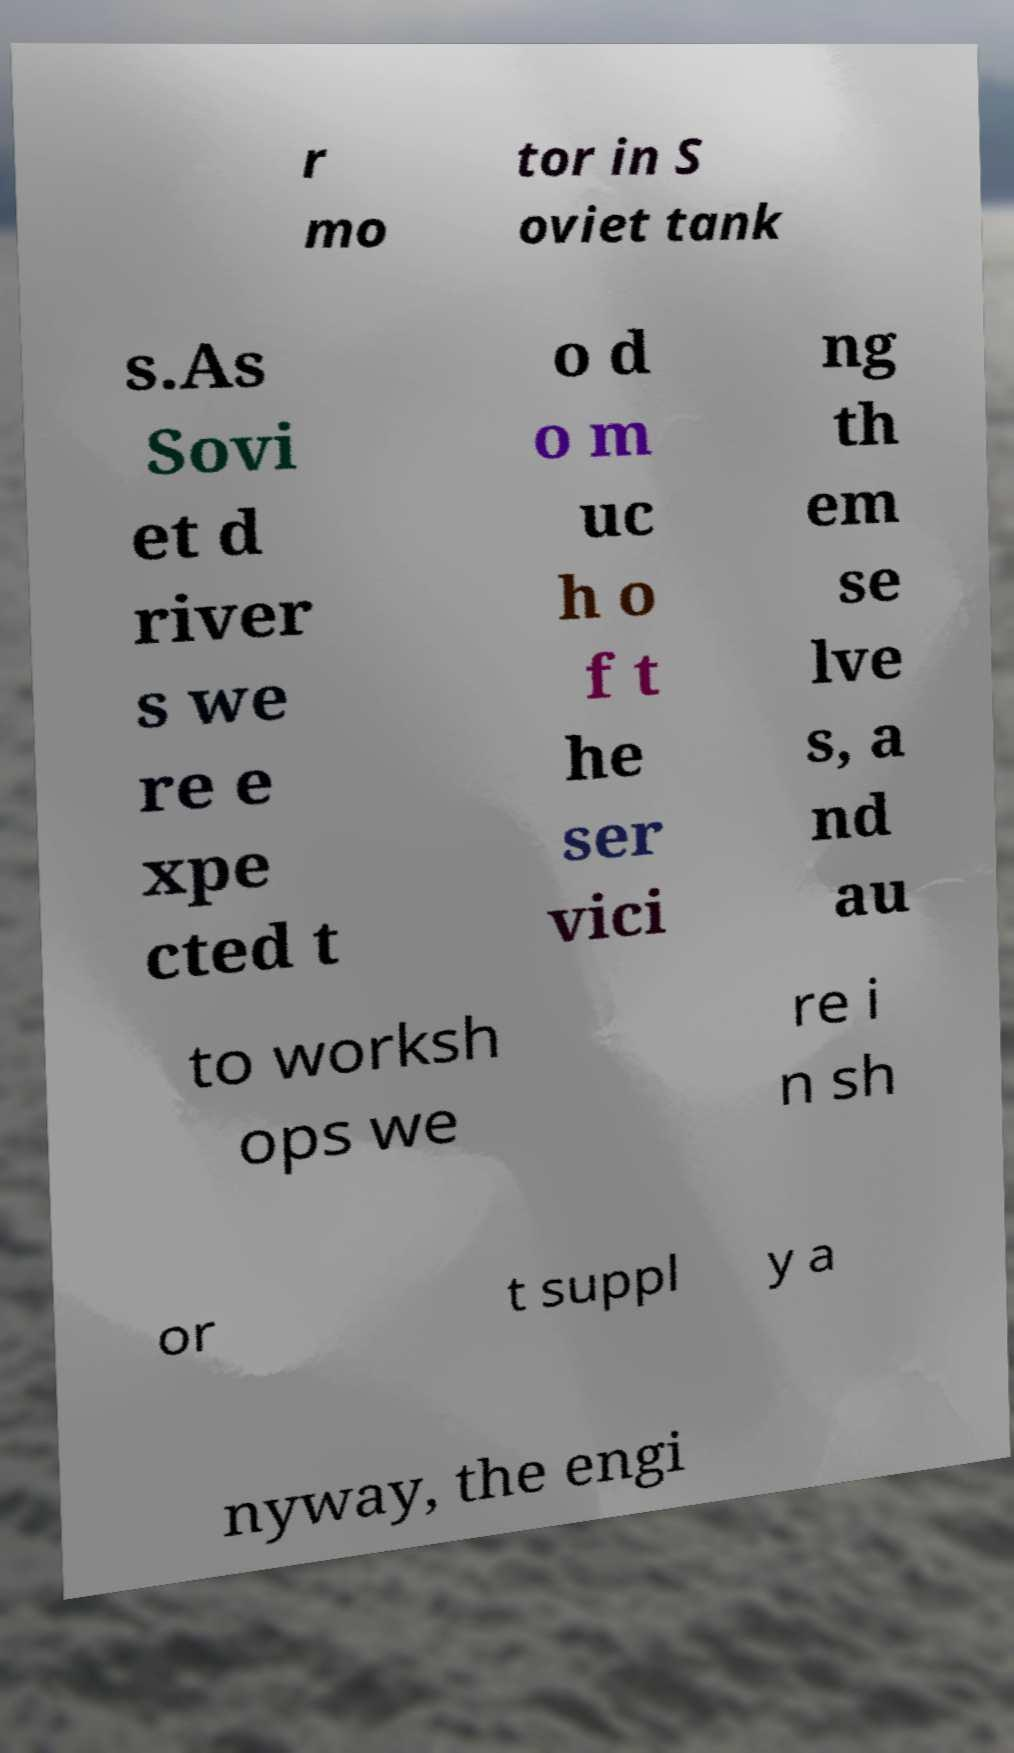I need the written content from this picture converted into text. Can you do that? r mo tor in S oviet tank s.As Sovi et d river s we re e xpe cted t o d o m uc h o f t he ser vici ng th em se lve s, a nd au to worksh ops we re i n sh or t suppl y a nyway, the engi 